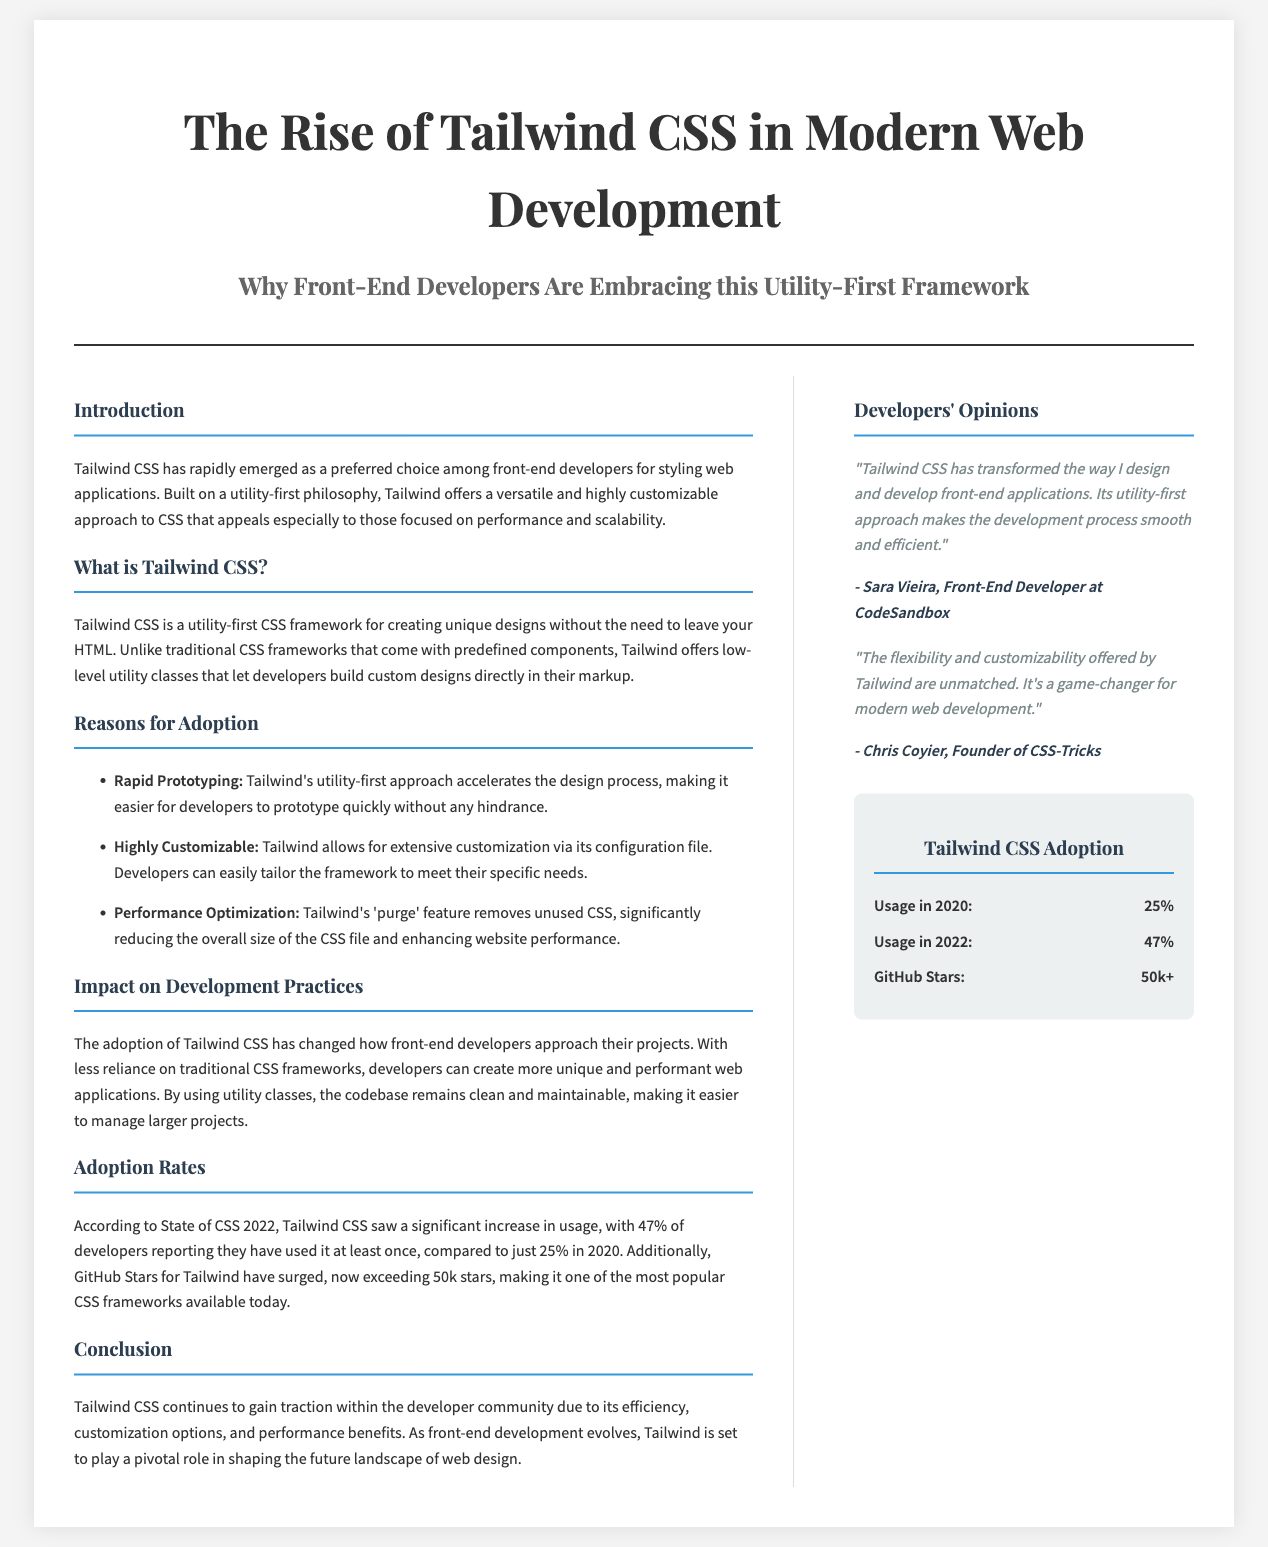What is the preferred choice among front-end developers for styling web applications? The document states that Tailwind CSS has rapidly emerged as a preferred choice among front-end developers for styling web applications.
Answer: Tailwind CSS What unique approach does Tailwind CSS utilize? The document explains that Tailwind CSS is built on a utility-first philosophy.
Answer: Utility-first What is the percentage of developers who reported using Tailwind CSS in 2022? According to the document, 47% of developers reported using Tailwind CSS in 2022.
Answer: 47% Who is the founder of CSS-Tricks? The document attributes the quote about Tailwind's flexibility and customizability to Chris Coyier, who is the founder of CSS-Tricks.
Answer: Chris Coyier What was Tailwind CSS usage in 2020? The document states that the usage in 2020 was 25%.
Answer: 25% In what year did Tailwind CSS usage increase to 47%? The document indicates that Tailwind CSS usage increased to 47% in 2022.
Answer: 2022 What is the name of the utility-first CSS framework highlighted in the document? The document identifies Tailwind CSS as the highlighted utility-first CSS framework.
Answer: Tailwind CSS Which section features a quote from Sara Vieira? The document mentions that the quote from Sara Vieira is found in the "Developers' Opinions" section.
Answer: Developers' Opinions How many GitHub stars does Tailwind CSS exceed according to the document? The document states that GitHub Stars for Tailwind have surged, now exceeding 50k stars.
Answer: 50k+ What is stated as one of the reasons for adopting Tailwind CSS? The document lists rapid prototyping, customization, and performance optimization as reasons for adoption.
Answer: Rapid Prototyping 